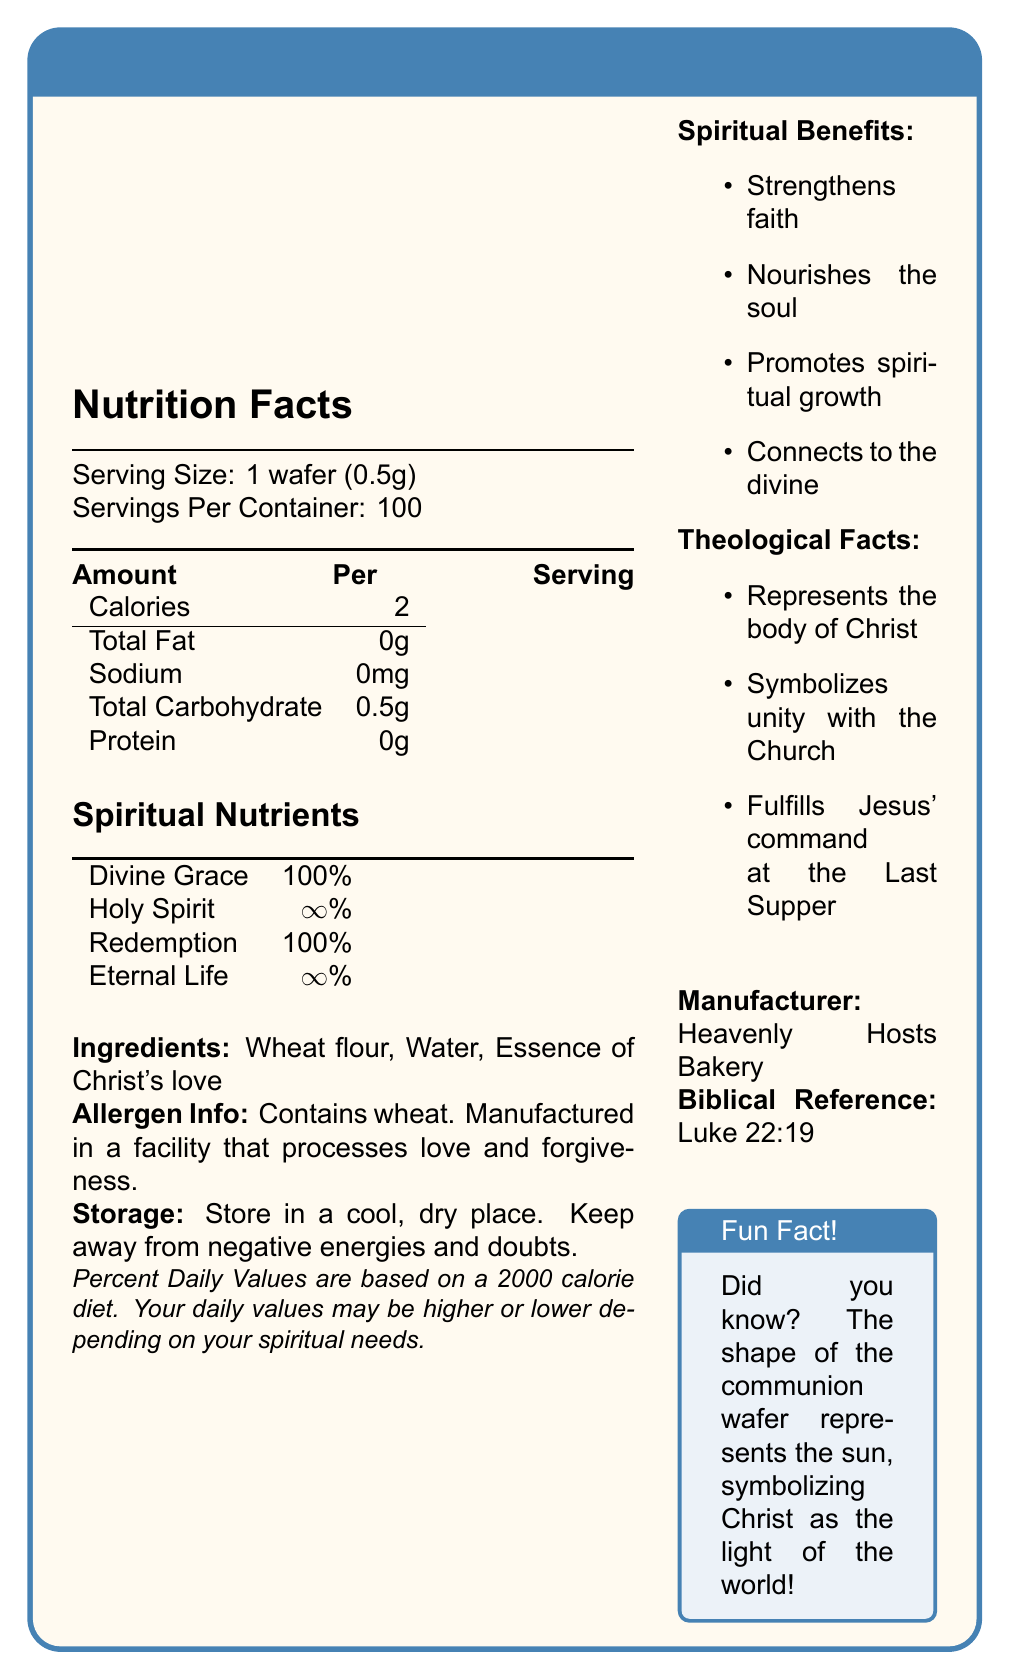what are the spiritual nutrients included in the communion wafer? The section titled "Spiritual Nutrients" lists these nutrients.
Answer: Divine Grace, Holy Spirit, Redemption, Eternal Life who is the manufacturer of the Divine Grace Communion Wafer? The manufacturer is mentioned at the bottom of the document.
Answer: Heavenly Hosts Bakery what ingredient is mentioned as being processed in the facility along with love and forgiveness? The allergen info mentions that it contains wheat and is processed in a facility that processes love and forgiveness.
Answer: Wheat where should the communion wafer be stored? A. In a refrigerator B. In a cool, dry place C. Next to holy water D. In direct sunlight The storage instructions specify to store the wafer in a cool, dry place.
Answer: B which of the following is a theological fact about the communion wafer? A. Represents the body of Christ B. Contains vitamins C. Made of gluten-free ingredients D. Best consumed during festivities The theological facts section specifies that the wafer represents the body of Christ.
Answer: A is the essence of Christ's love an ingredient in the Divine Grace Communion Wafer? The ingredients section lists Essence of Christ's love as one of the ingredients.
Answer: Yes what biblical reference is associated with the Divine Grace Communion Wafer? The biblical reference is stated at the bottom of the document as Luke 22:19.
Answer: Luke 22:19 does the Divine Grace Communion Wafer contain any sodium? The nutrition facts state that the wafer contains 0mg of sodium.
Answer: No summarize the main idea of the Divine Grace Communion Wafer document. The document is a comprehensive overview of the Divine Grace Communion Wafer, emphasizing both its physical nutritional content and its spiritual significance.
Answer: The document provides detailed nutritional and spiritual information about the Divine Grace Communion Wafer. It outlines serving size, calories, ingredients, and spiritual benefits, along with theological significance and storage instructions. It also includes a biblical reference and fun fact about the wafer's symbolism. what is the fun fact mentioned about the communion wafer? The fun fact section at the bottom of the document provides this information.
Answer: The shape of the communion wafer represents the sun, symbolizing Christ as the light of the world. can we determine from the document how often the communion wafer should be consumed? The document does not provide any guidelines on the frequency of consumption for the communion wafer.
Answer: Not enough information 